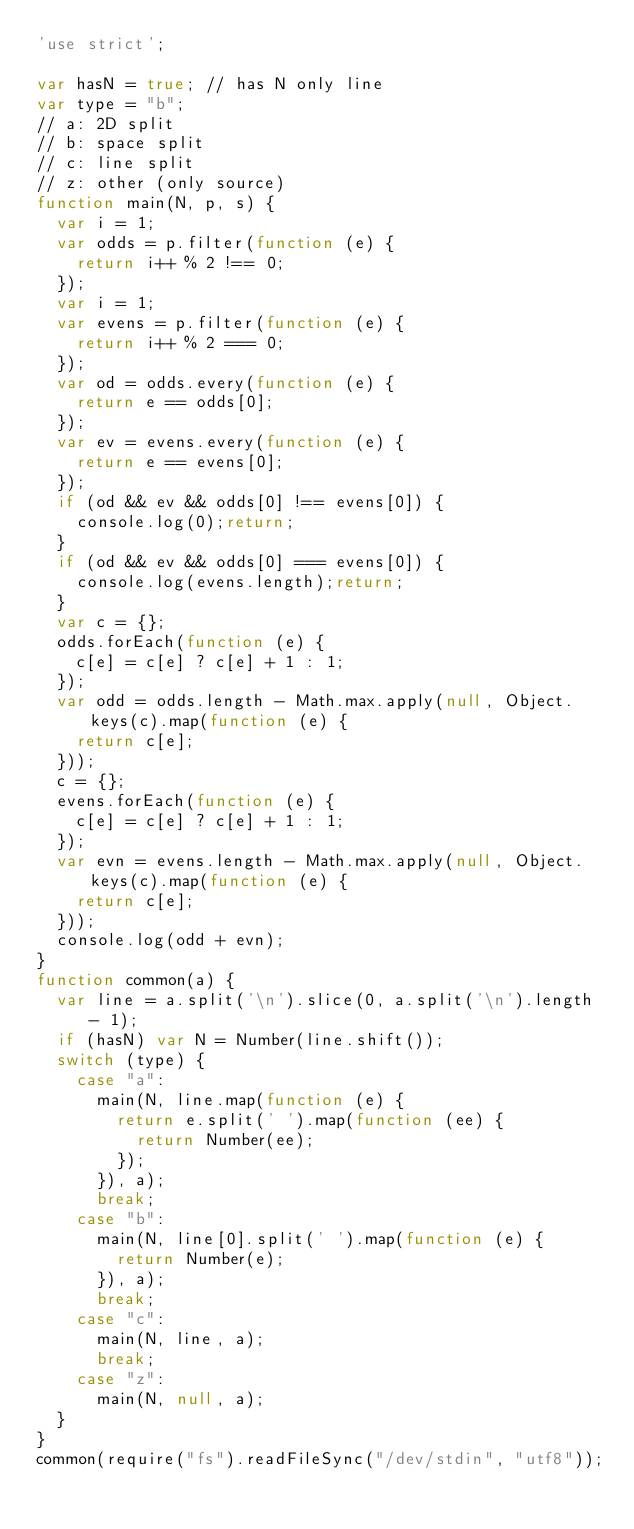<code> <loc_0><loc_0><loc_500><loc_500><_JavaScript_>'use strict';

var hasN = true; // has N only line
var type = "b";
// a: 2D split
// b: space split
// c: line split
// z: other (only source)
function main(N, p, s) {
	var i = 1;
	var odds = p.filter(function (e) {
		return i++ % 2 !== 0;
	});
	var i = 1;
	var evens = p.filter(function (e) {
		return i++ % 2 === 0;
	});
	var od = odds.every(function (e) {
		return e == odds[0];
	});
	var ev = evens.every(function (e) {
		return e == evens[0];
	});
	if (od && ev && odds[0] !== evens[0]) {
		console.log(0);return;
	}
	if (od && ev && odds[0] === evens[0]) {
		console.log(evens.length);return;
	}
	var c = {};
	odds.forEach(function (e) {
		c[e] = c[e] ? c[e] + 1 : 1;
	});
	var odd = odds.length - Math.max.apply(null, Object.keys(c).map(function (e) {
		return c[e];
	}));
	c = {};
	evens.forEach(function (e) {
		c[e] = c[e] ? c[e] + 1 : 1;
	});
	var evn = evens.length - Math.max.apply(null, Object.keys(c).map(function (e) {
		return c[e];
	}));
	console.log(odd + evn);
}
function common(a) {
	var line = a.split('\n').slice(0, a.split('\n').length - 1);
	if (hasN) var N = Number(line.shift());
	switch (type) {
		case "a":
			main(N, line.map(function (e) {
				return e.split(' ').map(function (ee) {
					return Number(ee);
				});
			}), a);
			break;
		case "b":
			main(N, line[0].split(' ').map(function (e) {
				return Number(e);
			}), a);
			break;
		case "c":
			main(N, line, a);
			break;
		case "z":
			main(N, null, a);
	}
}
common(require("fs").readFileSync("/dev/stdin", "utf8"));
</code> 